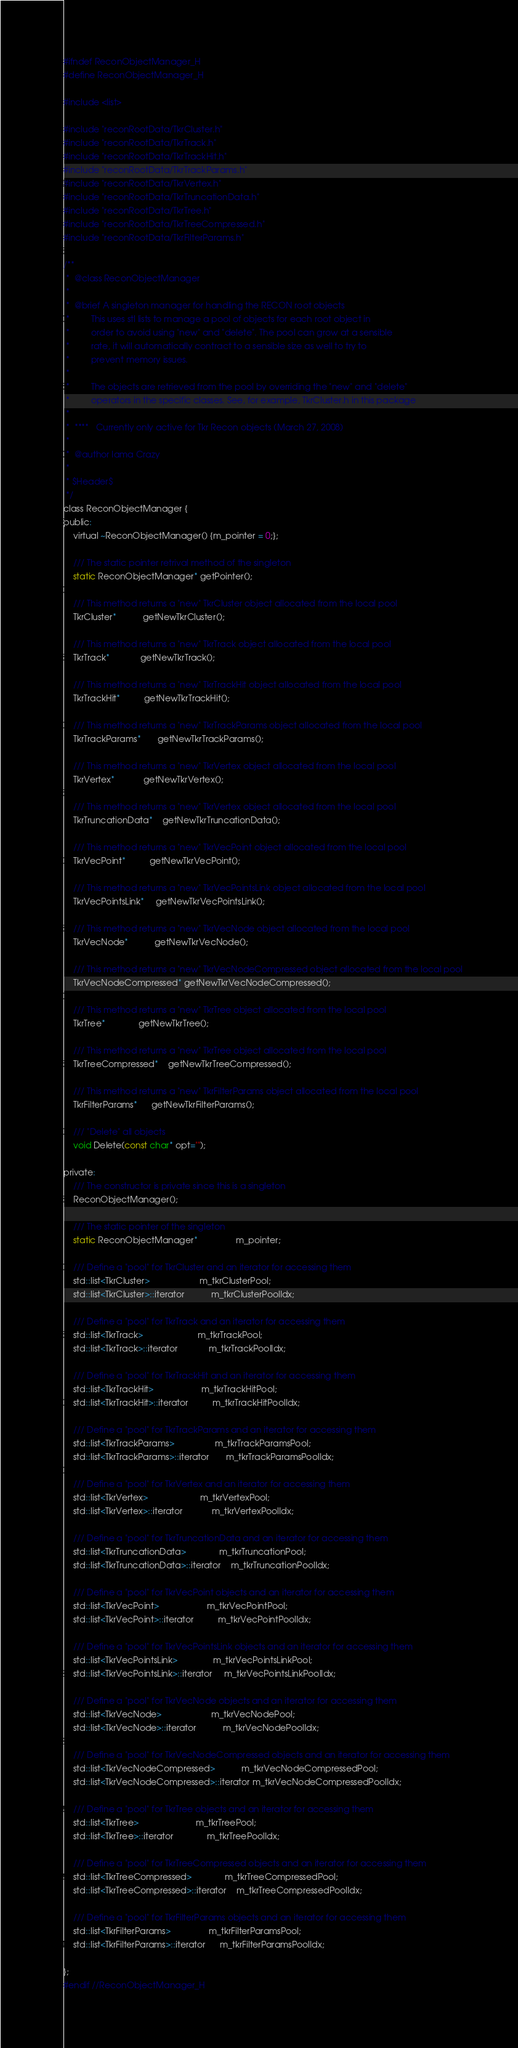<code> <loc_0><loc_0><loc_500><loc_500><_C_>#ifndef ReconObjectManager_H
#define ReconObjectManager_H

#include <list>

#include "reconRootData/TkrCluster.h"
#include "reconRootData/TkrTrack.h"
#include "reconRootData/TkrTrackHit.h"
#include "reconRootData/TkrTrackParams.h"
#include "reconRootData/TkrVertex.h"
#include "reconRootData/TkrTruncationData.h"
#include "reconRootData/TkrTree.h"
#include "reconRootData/TkrTreeCompressed.h"
#include "reconRootData/TkrFilterParams.h"

/** 
 *  @class ReconObjectManager
 *
 *  @brief A singleton manager for handling the RECON root objects
 *         This uses stl lists to manage a pool of objects for each root object in
 *         order to avoid using "new" and "delete". The pool can grow at a sensible 
 *         rate, it will automatically contract to a sensible size as well to try to
 *         prevent memory issues. 
 * 
 *         The objects are retrieved from the pool by overriding the "new" and "delete"
 *         operators in the specific classes. See, for example, TkrCluster.h in this package
 *
 *  ****   Currently only active for Tkr Recon objects (March 27, 2008)
 *
 *  @author Iama Crazy
 *
 * $Header$
 */
class ReconObjectManager {
public:
    virtual ~ReconObjectManager() {m_pointer = 0;};

    /// The static pointer retrival method of the singleton
    static ReconObjectManager* getPointer();

    /// This method returns a "new" TkrCluster object allocated from the local pool
    TkrCluster*           getNewTkrCluster();

    /// This method returns a "new" TkrTrack object allocated from the local pool
    TkrTrack*             getNewTkrTrack();

    /// This method returns a "new" TkrTrackHit object allocated from the local pool
    TkrTrackHit*          getNewTkrTrackHit();

    /// This method returns a "new" TkrTrackParams object allocated from the local pool
    TkrTrackParams*       getNewTkrTrackParams();

    /// This method returns a "new" TkrVertex object allocated from the local pool
    TkrVertex*            getNewTkrVertex();

    /// This method returns a "new" TkrVertex object allocated from the local pool
    TkrTruncationData*    getNewTkrTruncationData();

    /// This method returns a "new" TkrVecPoint object allocated from the local pool
    TkrVecPoint*          getNewTkrVecPoint();

    /// This method returns a "new" TkrVecPointsLink object allocated from the local pool
    TkrVecPointsLink*     getNewTkrVecPointsLink();

    /// This method returns a "new" TkrVecNode object allocated from the local pool
    TkrVecNode*           getNewTkrVecNode();

    /// This method returns a "new" TkrVecNodeCompressed object allocated from the local pool
    TkrVecNodeCompressed* getNewTkrVecNodeCompressed();

    /// This method returns a "new" TkrTree object allocated from the local pool
    TkrTree*              getNewTkrTree();

    /// This method returns a "new" TkrTree object allocated from the local pool
    TkrTreeCompressed*    getNewTkrTreeCompressed();

    /// This method returns a "new" TkrFilterParams object allocated from the local pool
    TkrFilterParams*      getNewTkrFilterParams();

    /// "Delete" all objects
    void Delete(const char* opt="");

private:
    /// The constructor is private since this is a singleton
    ReconObjectManager();   

    /// The static pointer of the singleton
    static ReconObjectManager*                m_pointer;

    /// Define a "pool" for TkrCluster and an iterator for accessing them
    std::list<TkrCluster>                     m_tkrClusterPool;
    std::list<TkrCluster>::iterator           m_tkrClusterPoolIdx;

    /// Define a "pool" for TkrTrack and an iterator for accessing them
    std::list<TkrTrack>                       m_tkrTrackPool;
    std::list<TkrTrack>::iterator             m_tkrTrackPoolIdx;

    /// Define a "pool" for TkrTrackHit and an iterator for accessing them
    std::list<TkrTrackHit>                    m_tkrTrackHitPool;
    std::list<TkrTrackHit>::iterator          m_tkrTrackHitPoolIdx;

    /// Define a "pool" for TkrTrackParams and an iterator for accessing them
    std::list<TkrTrackParams>                 m_tkrTrackParamsPool;
    std::list<TkrTrackParams>::iterator       m_tkrTrackParamsPoolIdx;

    /// Define a "pool" for TkrVertex and an iterator for accessing them
    std::list<TkrVertex>                      m_tkrVertexPool;
    std::list<TkrVertex>::iterator            m_tkrVertexPoolIdx;

    /// Define a "pool" for TkrTruncationData and an iterator for accessing them
    std::list<TkrTruncationData>              m_tkrTruncationPool;
    std::list<TkrTruncationData>::iterator    m_tkrTruncationPoolIdx;

    /// Define a "pool" for TkrVecPoint objects and an iterator for accessing them
    std::list<TkrVecPoint>                    m_tkrVecPointPool;
    std::list<TkrVecPoint>::iterator          m_tkrVecPointPoolIdx;

    /// Define a "pool" for TkrVecPointsLink objects and an iterator for accessing them
    std::list<TkrVecPointsLink>               m_tkrVecPointsLinkPool;
    std::list<TkrVecPointsLink>::iterator     m_tkrVecPointsLinkPoolIdx;

    /// Define a "pool" for TkrVecNode objects and an iterator for accessing them
    std::list<TkrVecNode>                     m_tkrVecNodePool;
    std::list<TkrVecNode>::iterator           m_tkrVecNodePoolIdx;

    /// Define a "pool" for TkrVecNodeCompressed objects and an iterator for accessing them
    std::list<TkrVecNodeCompressed>           m_tkrVecNodeCompressedPool;
    std::list<TkrVecNodeCompressed>::iterator m_tkrVecNodeCompressedPoolIdx;

    /// Define a "pool" for TkrTree objects and an iterator for accessing them
    std::list<TkrTree>                        m_tkrTreePool;
    std::list<TkrTree>::iterator              m_tkrTreePoolIdx;

    /// Define a "pool" for TkrTreeCompressed objects and an iterator for accessing them
    std::list<TkrTreeCompressed>              m_tkrTreeCompressedPool;
    std::list<TkrTreeCompressed>::iterator    m_tkrTreeCompressedPoolIdx;

    /// Define a "pool" for TkrFilterParams objects and an iterator for accessing them
    std::list<TkrFilterParams>                m_tkrFilterParamsPool;
    std::list<TkrFilterParams>::iterator      m_tkrFilterParamsPoolIdx;

};
#endif //ReconObjectManager_H
</code> 